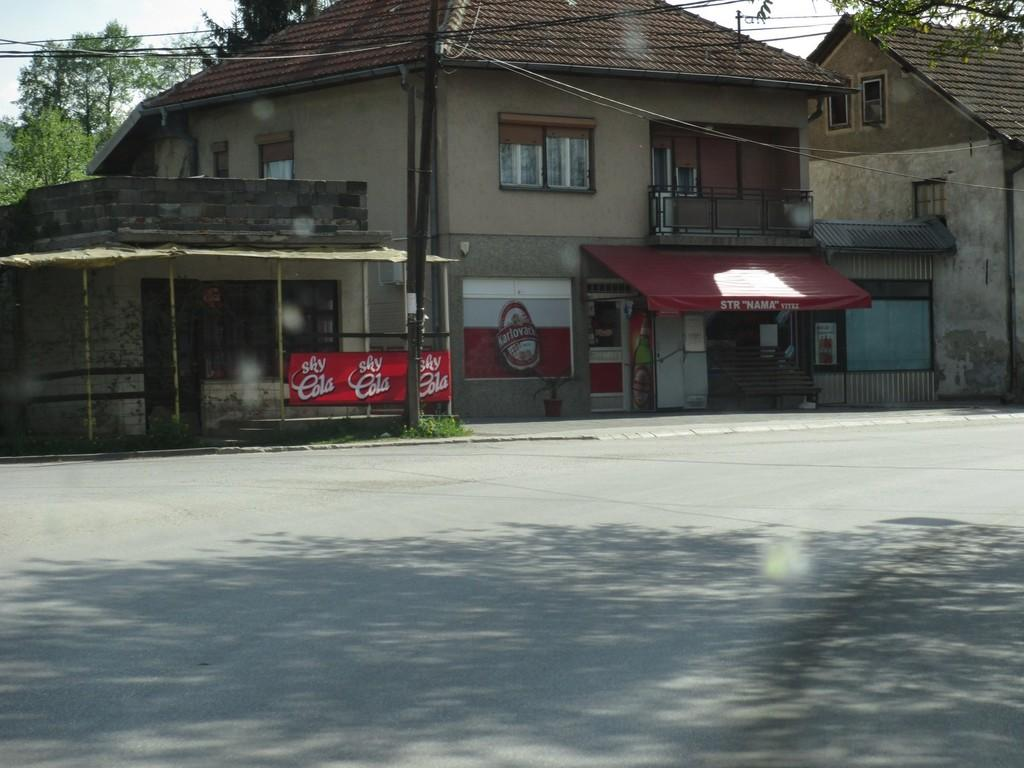What type of building is in the image? There is a house in the image. What is located below the house? There is a store below the house. What can be seen around the house? There are trees around the house. What else is visible in the image? There are wires in the image. What is the condition of the road in front of the house? The road in front of the house is empty. What type of birds can be seen flying over the office in the image? There is no office present in the image, and therefore no birds flying over it. 